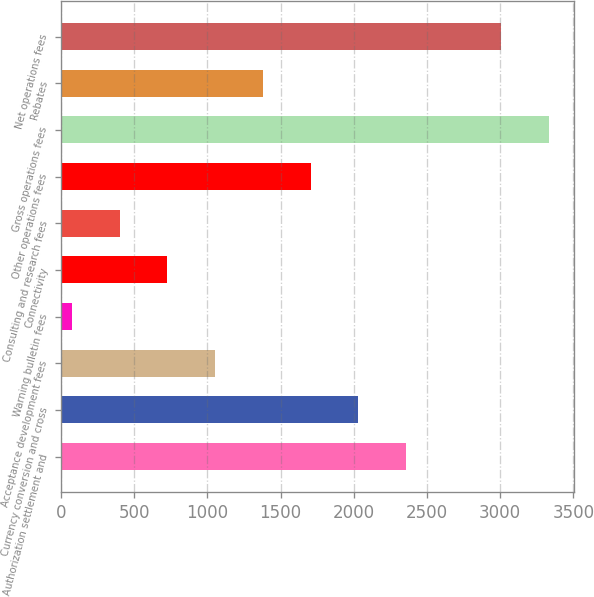Convert chart to OTSL. <chart><loc_0><loc_0><loc_500><loc_500><bar_chart><fcel>Authorization settlement and<fcel>Currency conversion and cross<fcel>Acceptance development fees<fcel>Warning bulletin fees<fcel>Connectivity<fcel>Consulting and research fees<fcel>Other operations fees<fcel>Gross operations fees<fcel>Rebates<fcel>Net operations fees<nl><fcel>2356.7<fcel>2030.6<fcel>1052.3<fcel>74<fcel>726.2<fcel>400.1<fcel>1704.5<fcel>3335<fcel>1378.4<fcel>3003<nl></chart> 